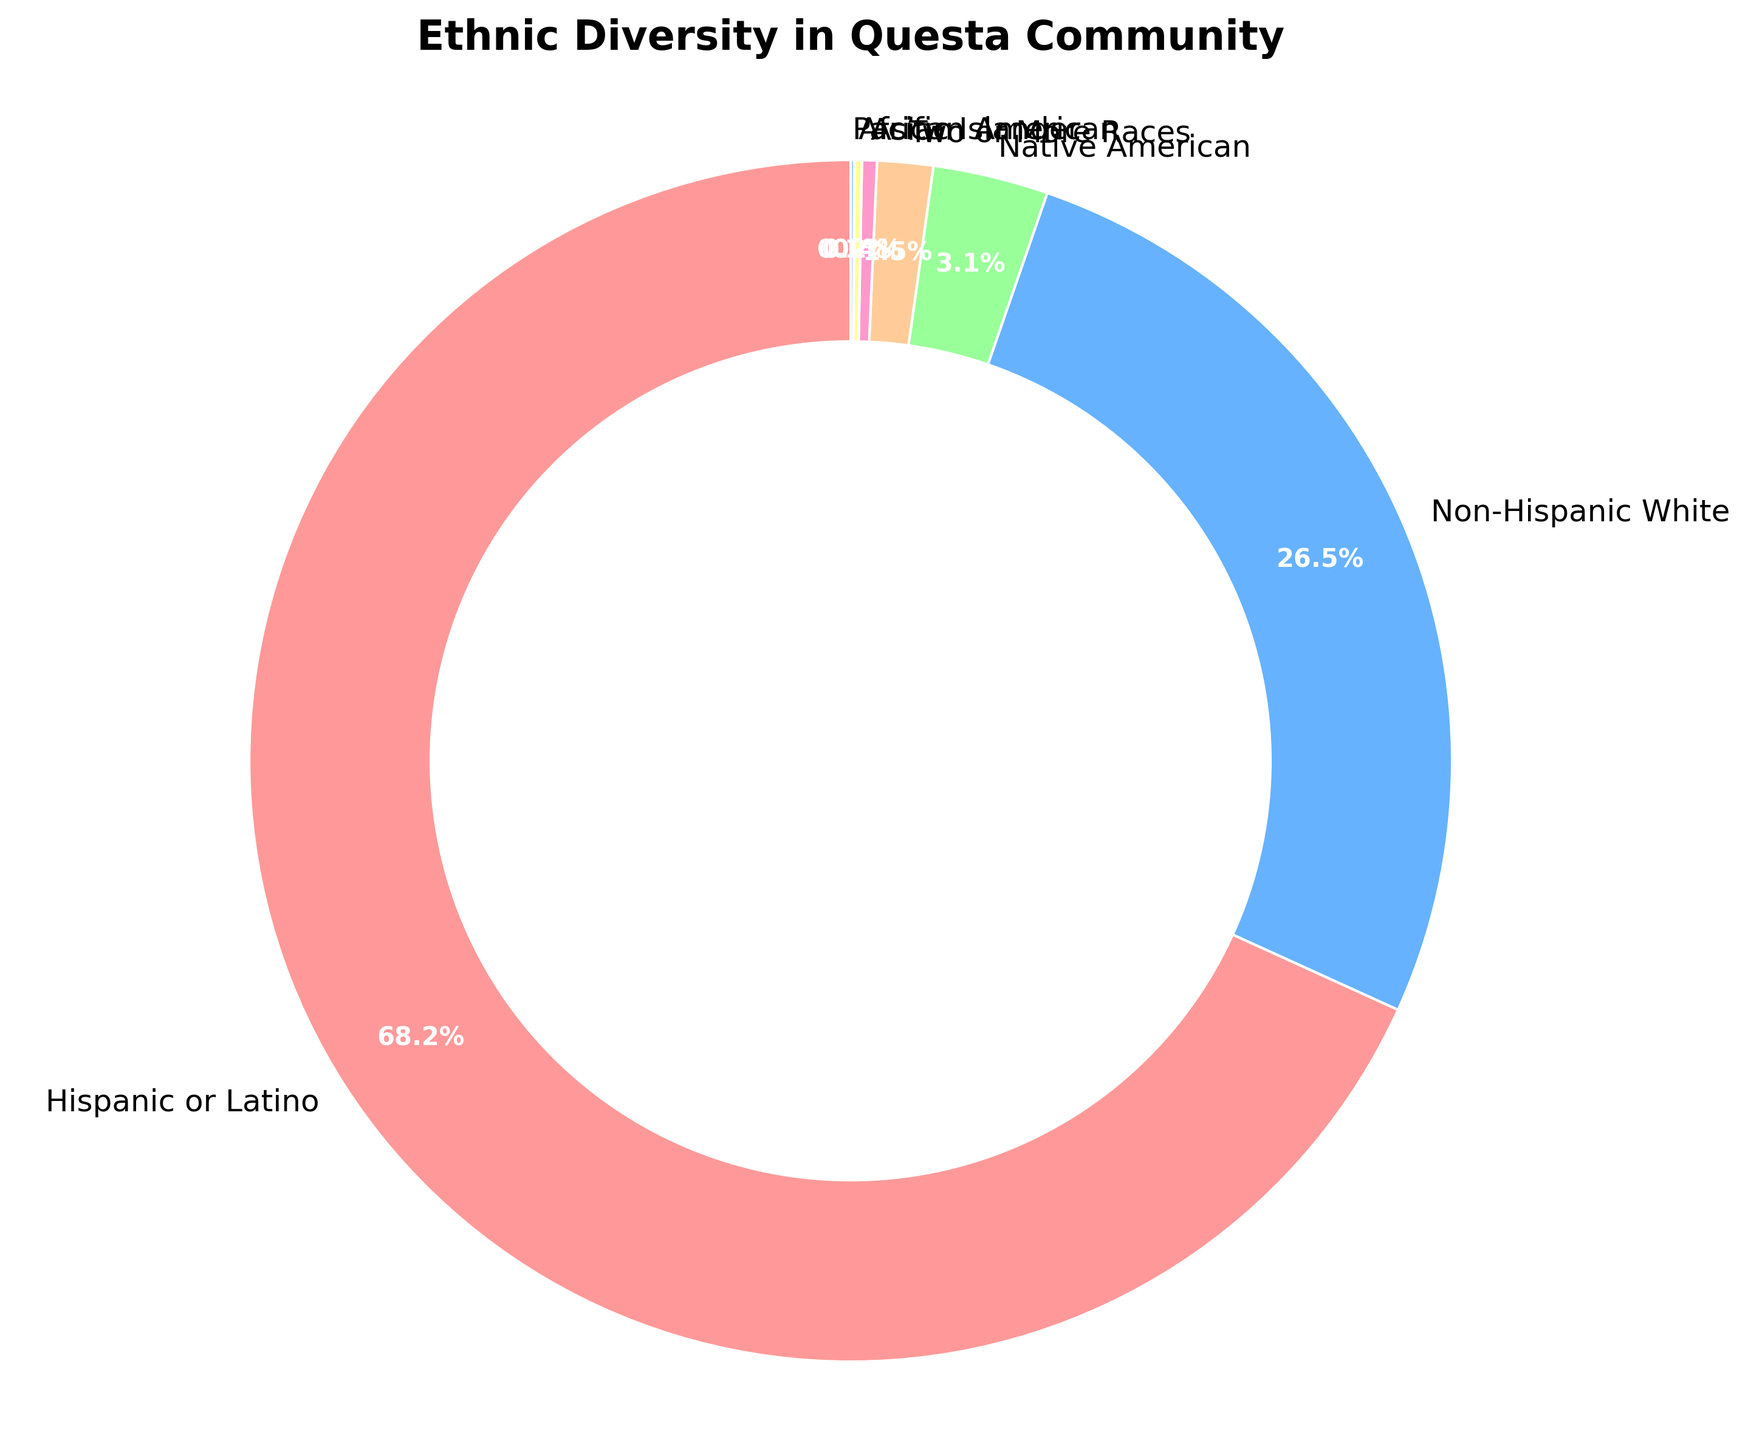Which ethnic group has the highest representation in Questa Community? By observing the pie chart, we can see the largest segment which represents 68.2%. This segment corresponds to the "Hispanic or Latino" label, indicating the highest representation.
Answer: Hispanic or Latino What is the combined percentage of Native American and Asian groups? Adding the percentages of Native American (3.1%) and Asian (0.4%) from the pie chart, we get 3.1 + 0.4 = 3.5%.
Answer: 3.5% Which ethnic group has the smallest representation, and what is its percentage? The smallest segment in the pie chart is the one labeled "Pacific Islander" which is 0.1%.
Answer: Pacific Islander, 0.1% Is the percentage of Non-Hispanic White greater than the combined percentage of Native American, Two or More Races, Asian, African American, and Pacific Islander? Adding these percentages: Native American (3.1%), Two or More Races (1.5%), Asian (0.4%), African American (0.2%), and Pacific Islander (0.1%) gives us 3.1 + 1.5 + 0.4 + 0.2 + 0.1 = 5.3%. The percentage of Non-Hispanic White is 26.5%, which is clearly greater than 5.3%.
Answer: Yes How much larger is the percentage of Hispanic or Latino compared to Non-Hispanic White? Subtracting the percentage of Non-Hispanic White (26.5%) from Hispanic or Latino (68.2%) gives us 68.2 - 26.5 = 41.7%.
Answer: 41.7% What is the sum of the percentages of the smallest three ethnic groups? Adding the percentages of the smallest three groups: Pacific Islander (0.1%), African American (0.2%), and Asian (0.4%) gives us 0.1 + 0.2 + 0.4 = 0.7%.
Answer: 0.7% Which segment is displayed in green? By visually identifying the colors in the pie chart, the segment displayed in green corresponds to the "Two or More Races" group.
Answer: Two or More Races What is the percentage difference between Two or More Races and Native American groups? Subtracting the percentage of Two or More Races (1.5%) from Native American (3.1%) gives us 3.1 - 1.5 = 1.6%.
Answer: 1.6% How do the percentages of African American and Pacific Islander compare? The pie chart shows that African American has 0.2% and Pacific Islander has 0.1%. Therefore, African American is 0.1% higher than Pacific Islander.
Answer: African American > Pacific Islander 